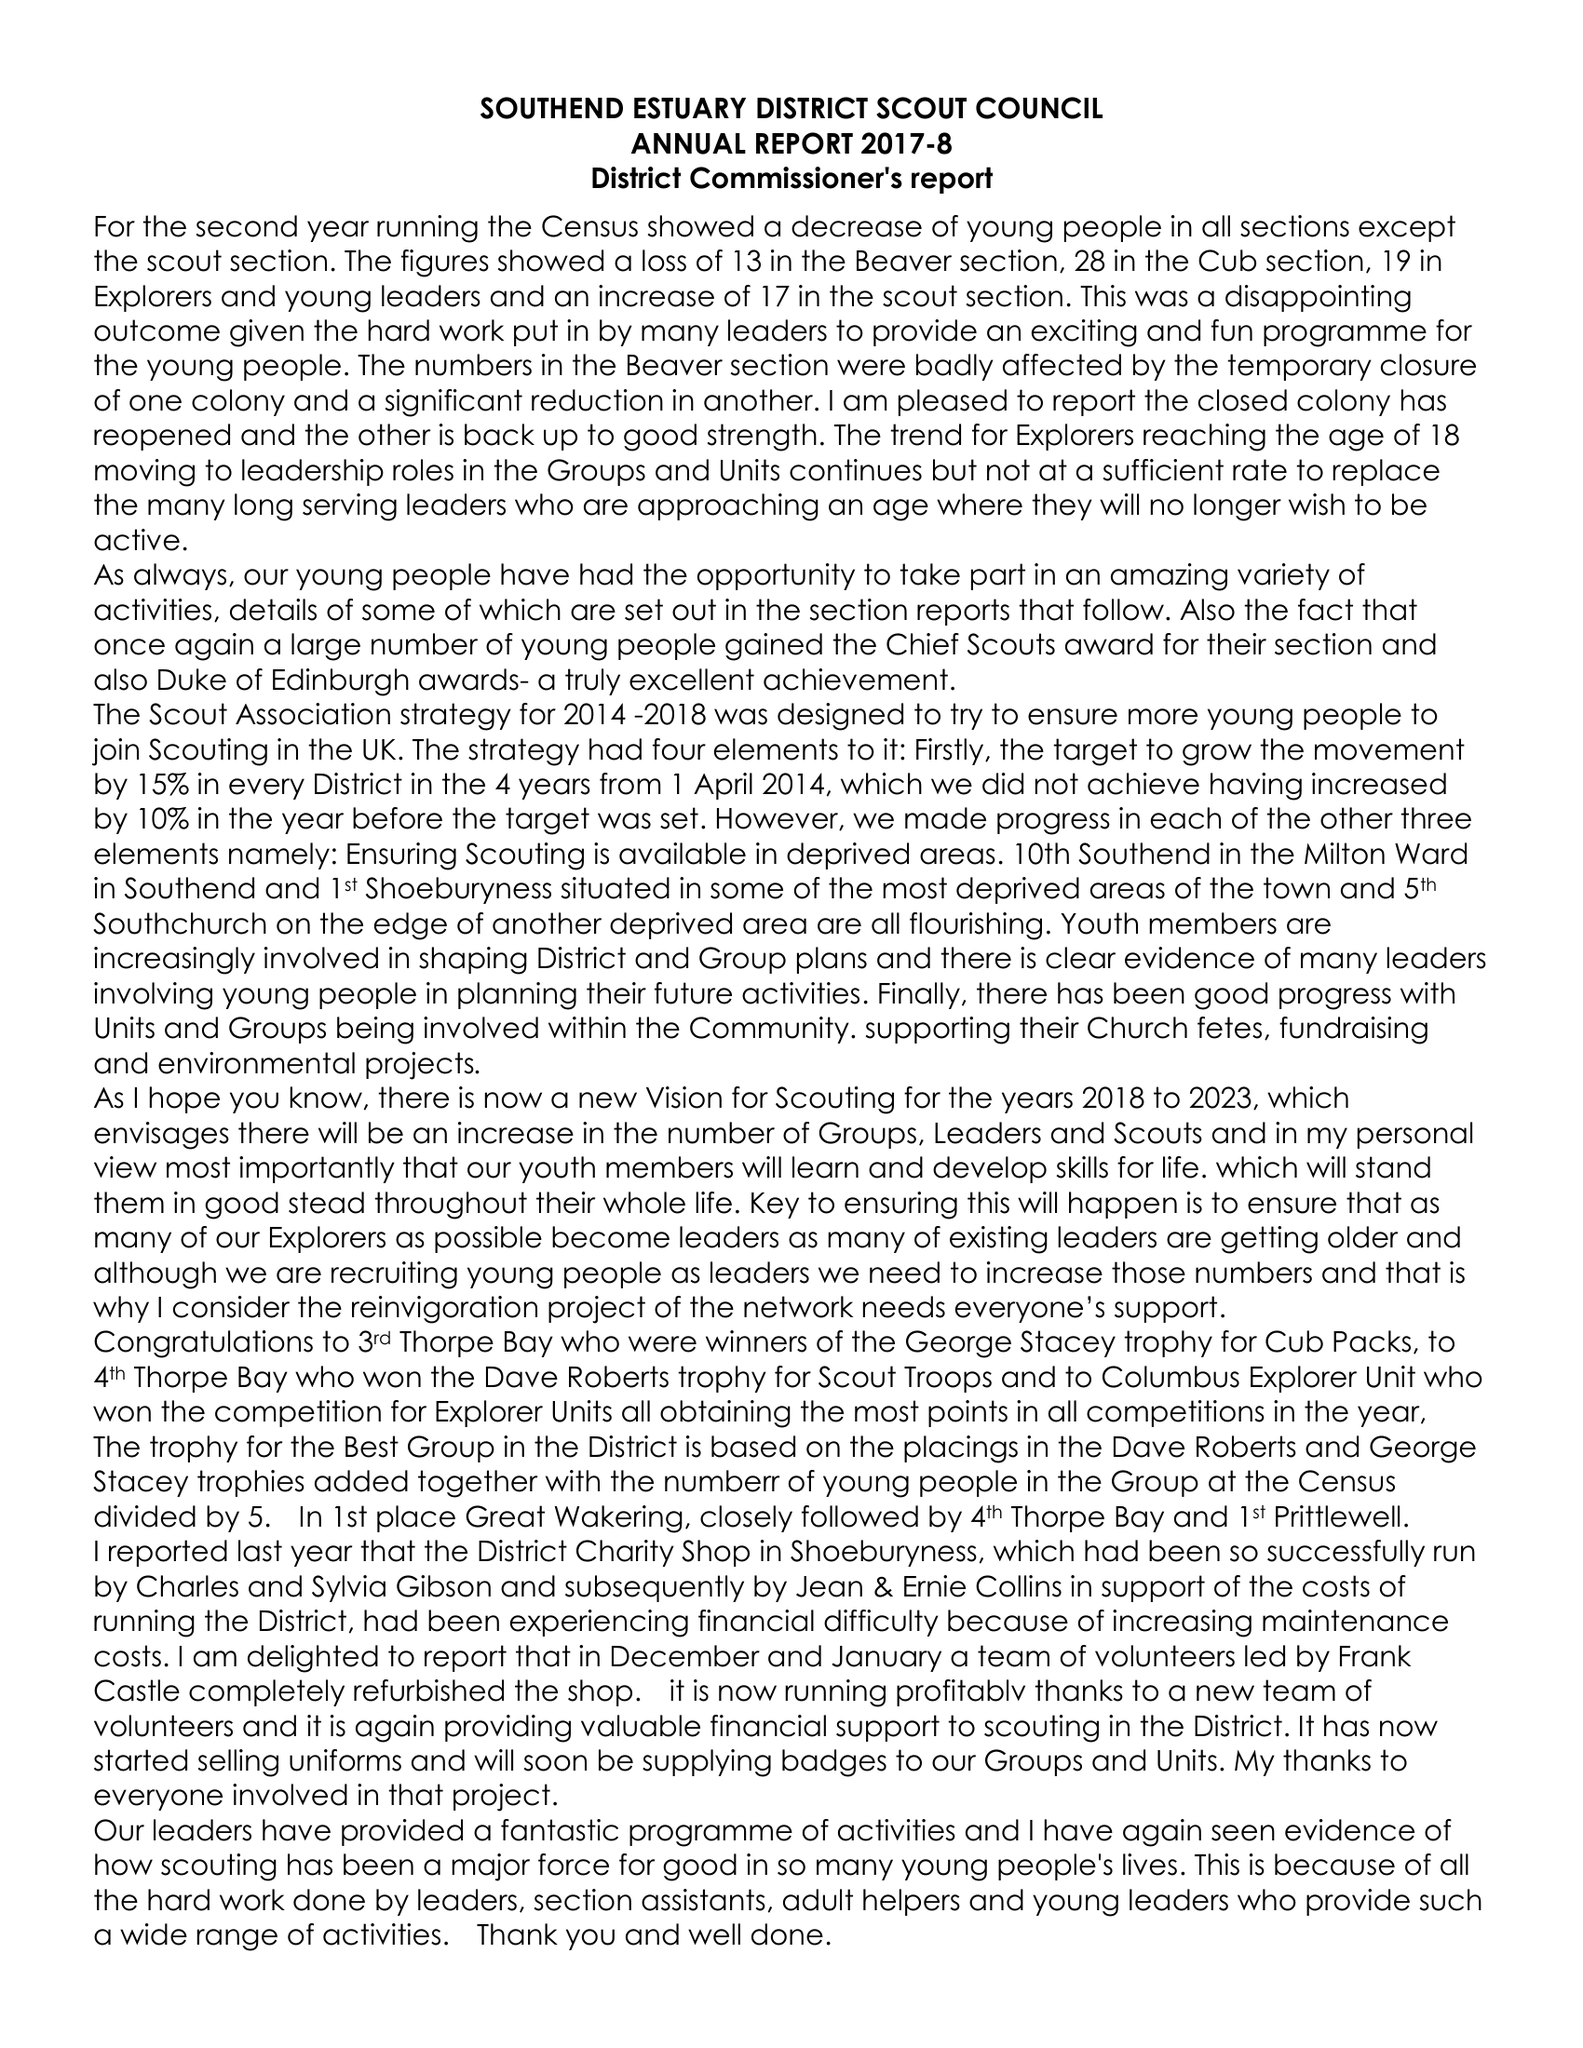What is the value for the address__post_town?
Answer the question using a single word or phrase. SOUTHEND-ON-SEA 